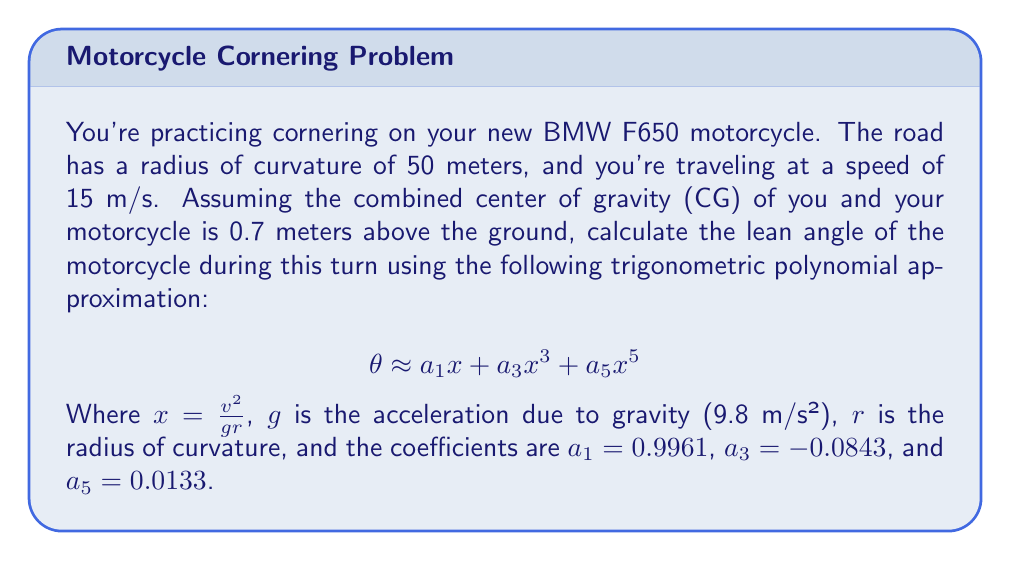Provide a solution to this math problem. Let's approach this step-by-step:

1) First, we need to calculate the value of $x$:
   $$ x = \frac{v^2}{gr} $$
   where $v = 15$ m/s, $g = 9.8$ m/s², and $r = 50$ m

   $$ x = \frac{15^2}{9.8 \cdot 50} = \frac{225}{490} \approx 0.4592 $$

2) Now we can substitute this value into our trigonometric polynomial approximation:
   $$ \theta \approx a_1x + a_3x^3 + a_5x^5 $$

3) Let's calculate each term:
   $a_1x = 0.9961 \cdot 0.4592 \approx 0.4574$
   $a_3x^3 = -0.0843 \cdot 0.4592^3 \approx -0.0082$
   $a_5x^5 = 0.0133 \cdot 0.4592^5 \approx 0.0001$

4) Adding these terms:
   $$ \theta \approx 0.4574 - 0.0082 + 0.0001 = 0.4493 $$

5) This result is in radians. To convert to degrees, we multiply by $\frac{180}{\pi}$:
   $$ \theta \approx 0.4493 \cdot \frac{180}{\pi} \approx 25.74° $$

Therefore, the lean angle of your BMW F650 during this turn is approximately 25.74°.
Answer: The lean angle of the motorcycle during the turn is approximately 25.74°. 